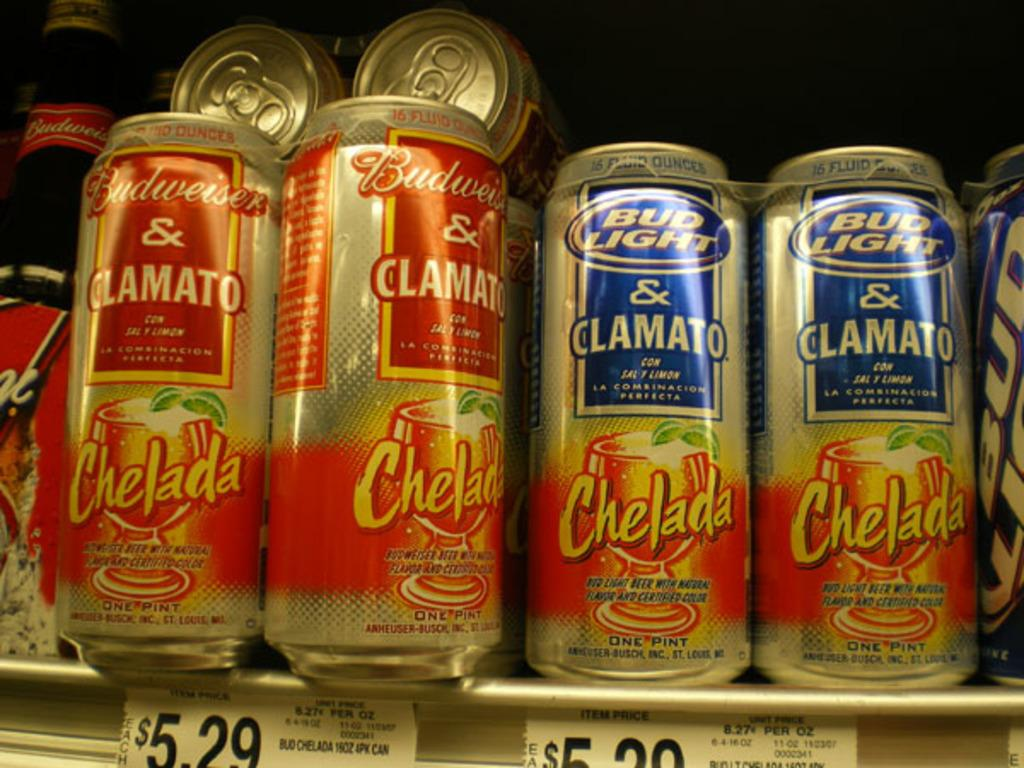<image>
Relay a brief, clear account of the picture shown. The cans of Budweiser & CLAMATO Chelada and Bud Light & CLAMATO Chelada are on a store shelf. 